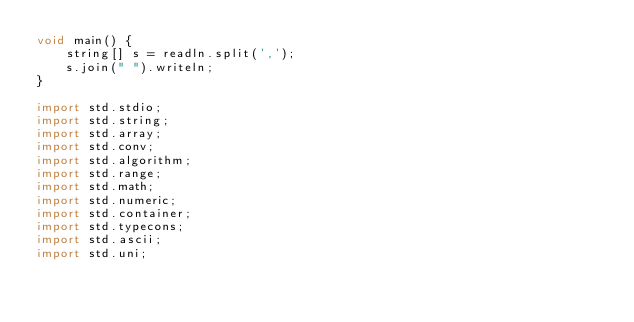<code> <loc_0><loc_0><loc_500><loc_500><_D_>void main() {
    string[] s = readln.split(',');
    s.join(" ").writeln;
}

import std.stdio;
import std.string;
import std.array;
import std.conv;
import std.algorithm;
import std.range;
import std.math;
import std.numeric;
import std.container;
import std.typecons;
import std.ascii;
import std.uni;</code> 